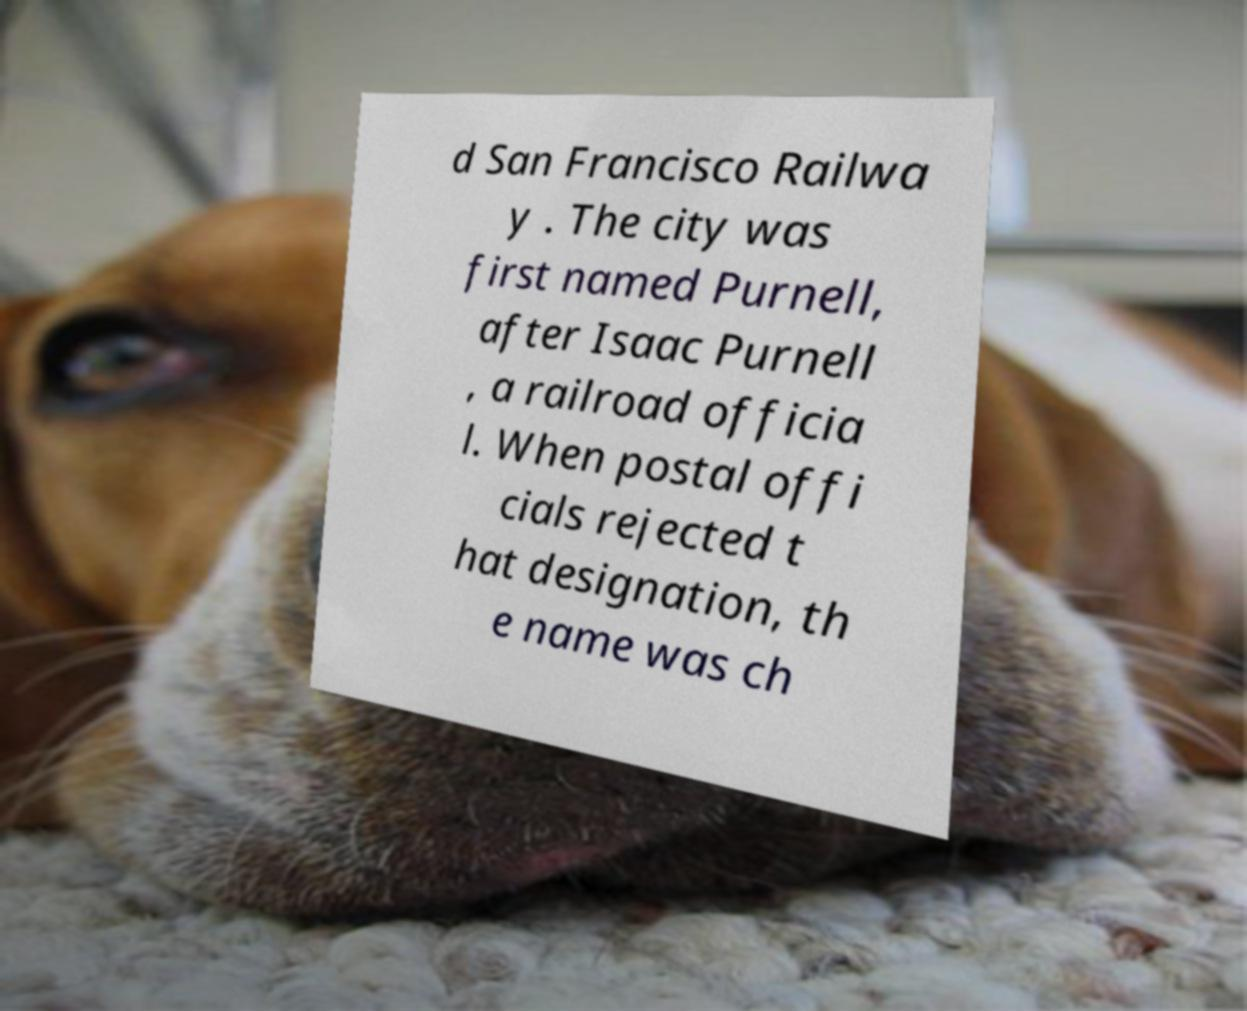For documentation purposes, I need the text within this image transcribed. Could you provide that? d San Francisco Railwa y . The city was first named Purnell, after Isaac Purnell , a railroad officia l. When postal offi cials rejected t hat designation, th e name was ch 